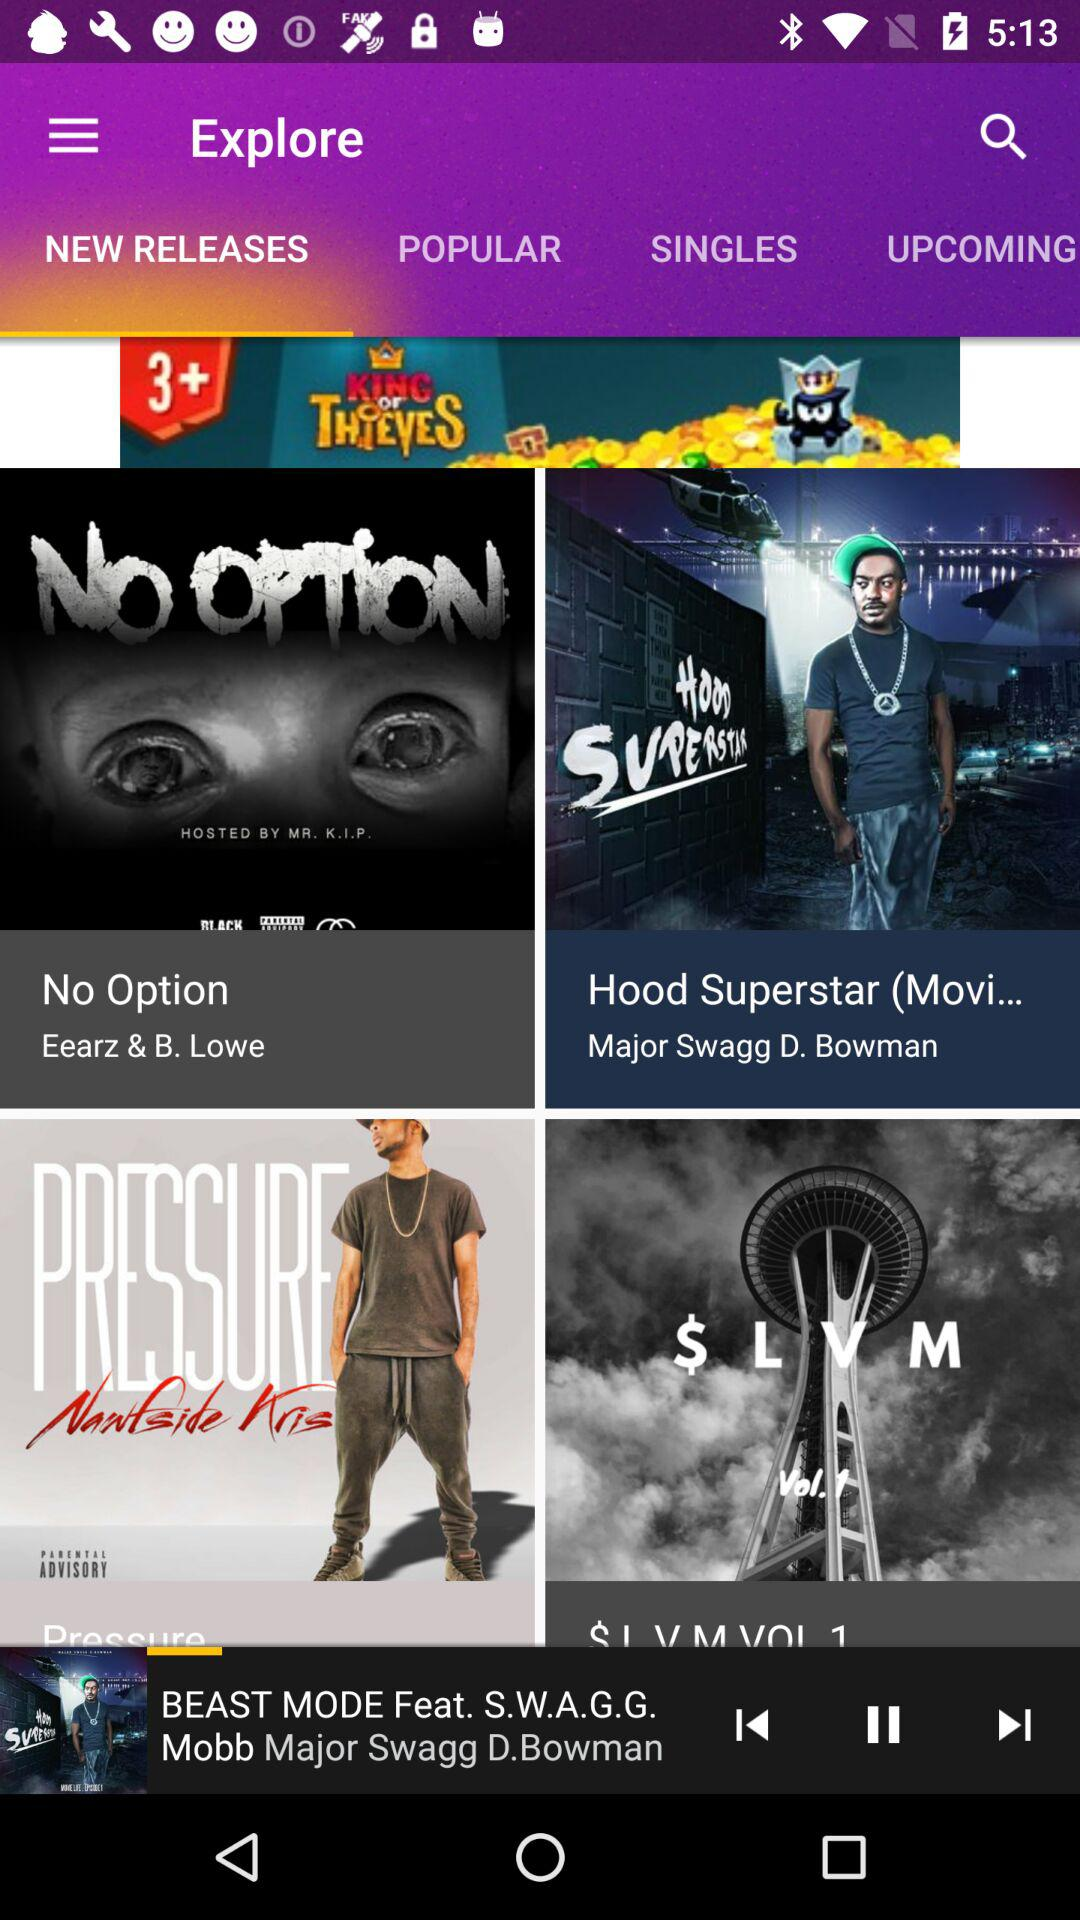Which song is currently playing? The song currently playing is "BEAST MODE". 